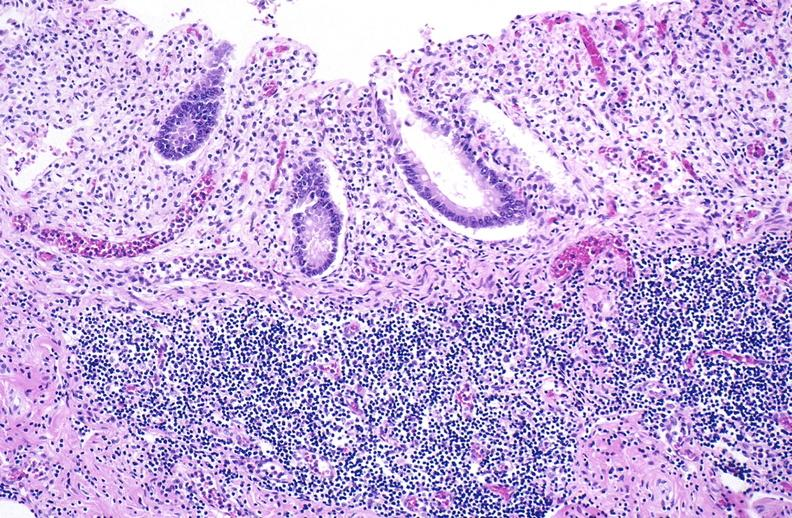does metastatic carcinoma oat cell show normal appendix?
Answer the question using a single word or phrase. No 